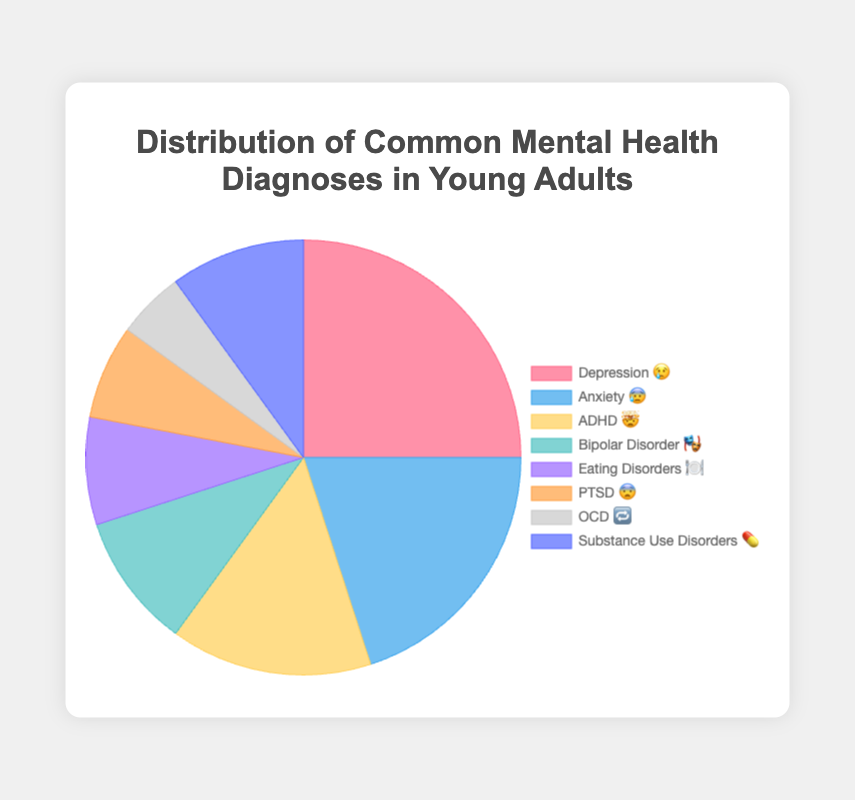What is the most common mental health diagnosis among young adults based on the chart? The chart shows that Depression (indicated by the emoji 😢) has the highest percentage.
Answer: Depression (😢) Which mental health diagnosis is represented by the emoji 💊? The chart indicates that Substance Use Disorders are represented by the emoji 💊.
Answer: Substance Use Disorders (💊) How many different mental health diagnoses are displayed on the chart? The chart has 8 different diagnoses, each represented by an emoji and a segment in the pie chart.
Answer: 8 What's the combined percentage of Bipolar Disorder 🎭 and Substance Use Disorders 💊? Bipolar Disorder is 10% and Substance Use Disorders is 10%, so the combined percentage is 10% + 10% = 20%.
Answer: 20% Which has a higher percentage, ADHD 🤯 or Eating Disorders 🍽️? By how much? ADHD has a percentage of 15%, and Eating Disorders have a percentage of 8%. The difference is 15% - 8% = 7%.
Answer: ADHD (🤯) by 7% What is the percentage for Anxiety 😰? The chart indicates that Anxiety is 20%.
Answer: 20% What is the least common mental health diagnosis shown on the chart? The chart shows that OCD (🔁) has the lowest percentage at 5%.
Answer: OCD (🔁) Comparing Depression 😢 and PTSD 😨, which one has a higher percentage and by how much? Depression has a percentage of 25% and PTSD has 7%, so Depression is higher by 25% - 7% = 18%.
Answer: Depression (😢) by 18% How does the percentage of Anxiety 😰 compare to the sum of Eating Disorders 🍽️ and PTSD 😨? Anxiety is 20%. Eating Disorders and PTSD together are 8% + 7% = 15%. Therefore, Anxiety is higher by 20% - 15% = 5%.
Answer: Anxiety (😰) by 5% Which three diagnoses have percentages that add up to 50%? The three largest categories are Depression (25%), Anxiety (20%), and ADHD (15%). Adding these gives 25% + 20% + 15% = 60%. Since this exceeds 50%, the next combination includes Bipolar Disorder (10%) replacing one: Depression (25%), Anxiety (20%), and Bipolar Disorder (10%). Adding these gives 25% + 20% + 10% = 55%. A valid combination can be Depression (25%), Anxiety (20%), and PTSD (7%), which totals 25% + 20% + 7% = 52%. Thus the precise combination must be Anxiety (20%), ADHD (15%), and Substance Use Disorders (10%), totaling 20% + 15% + 10% = 45% plus an additional 5% from OCD. Therefore a correction: Anxiety (20%), ADHD (15%), Eating Disorders (8%), PTSD (7%), totalling 20 + 15 + 8 + 7 = 50%.
Answer: Anxiety, ADHD, Eating Disorders, PTSD 